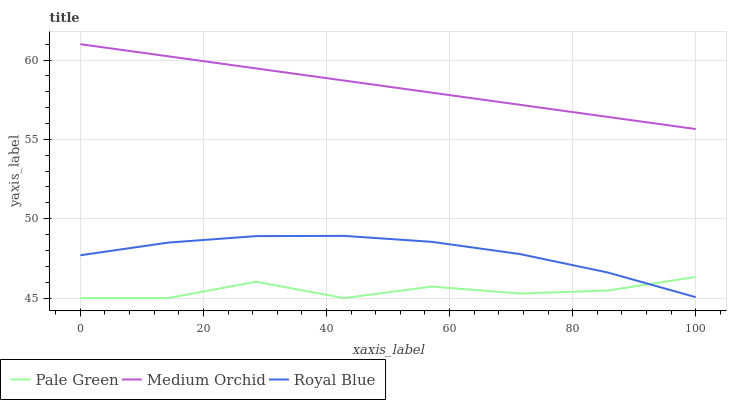Does Pale Green have the minimum area under the curve?
Answer yes or no. Yes. Does Medium Orchid have the maximum area under the curve?
Answer yes or no. Yes. Does Medium Orchid have the minimum area under the curve?
Answer yes or no. No. Does Pale Green have the maximum area under the curve?
Answer yes or no. No. Is Medium Orchid the smoothest?
Answer yes or no. Yes. Is Pale Green the roughest?
Answer yes or no. Yes. Is Pale Green the smoothest?
Answer yes or no. No. Is Medium Orchid the roughest?
Answer yes or no. No. Does Medium Orchid have the lowest value?
Answer yes or no. No. Does Pale Green have the highest value?
Answer yes or no. No. Is Royal Blue less than Medium Orchid?
Answer yes or no. Yes. Is Medium Orchid greater than Pale Green?
Answer yes or no. Yes. Does Royal Blue intersect Medium Orchid?
Answer yes or no. No. 